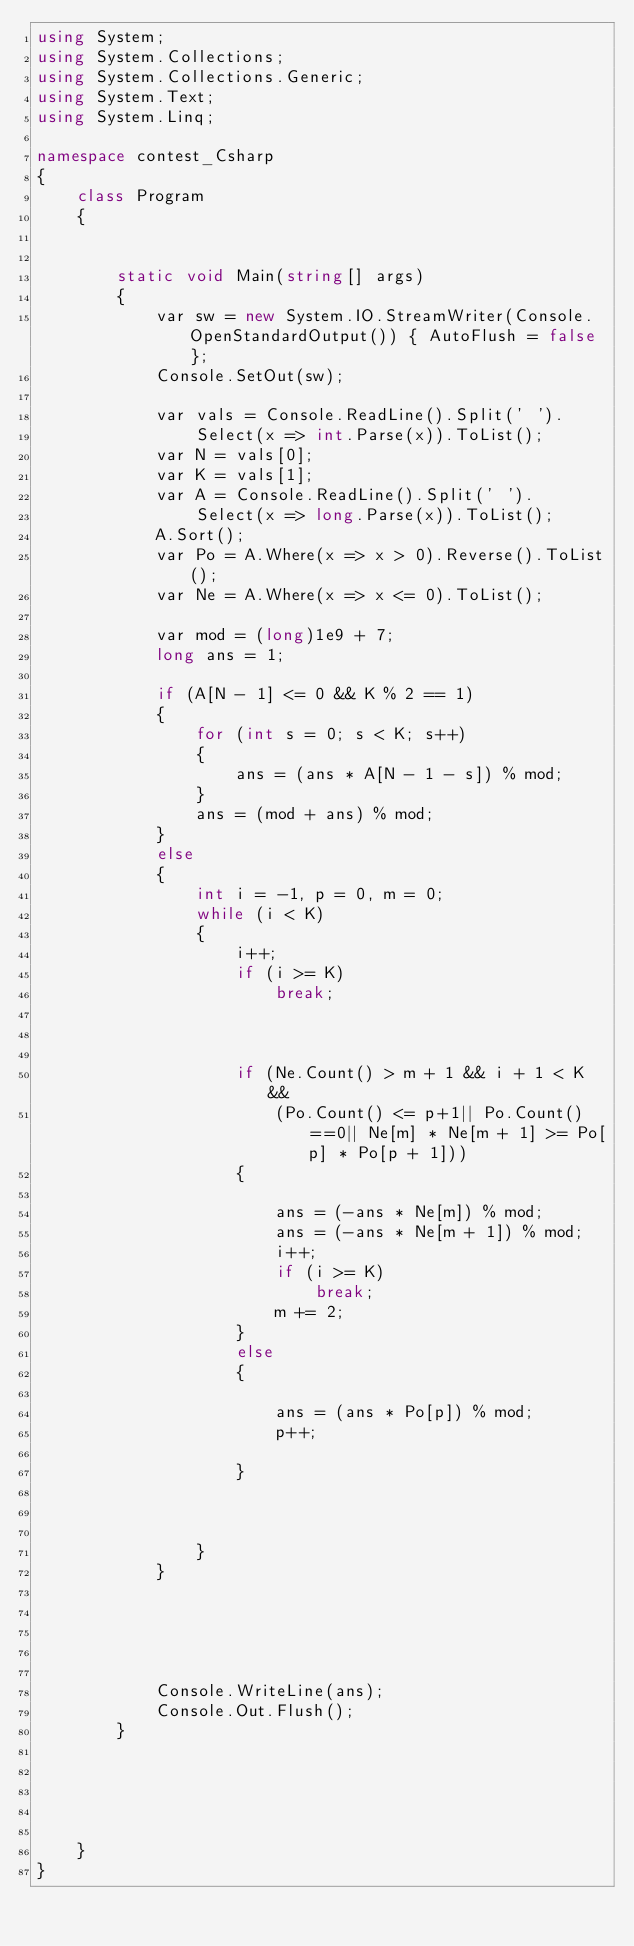<code> <loc_0><loc_0><loc_500><loc_500><_C#_>using System;
using System.Collections;
using System.Collections.Generic;
using System.Text;
using System.Linq;

namespace contest_Csharp
{
    class Program
    {


        static void Main(string[] args)
        {
            var sw = new System.IO.StreamWriter(Console.OpenStandardOutput()) { AutoFlush = false };
            Console.SetOut(sw);

            var vals = Console.ReadLine().Split(' ').
                Select(x => int.Parse(x)).ToList();
            var N = vals[0];
            var K = vals[1];
            var A = Console.ReadLine().Split(' ').
                Select(x => long.Parse(x)).ToList();
            A.Sort();
            var Po = A.Where(x => x > 0).Reverse().ToList();
            var Ne = A.Where(x => x <= 0).ToList();

            var mod = (long)1e9 + 7;
            long ans = 1;

            if (A[N - 1] <= 0 && K % 2 == 1)
            {
                for (int s = 0; s < K; s++)
                {
                    ans = (ans * A[N - 1 - s]) % mod;
                }
                ans = (mod + ans) % mod;
            }
            else
            {
                int i = -1, p = 0, m = 0;
                while (i < K)
                {
                    i++;
                    if (i >= K)
                        break;

                    

                    if (Ne.Count() > m + 1 && i + 1 < K &&
                        (Po.Count() <= p+1|| Po.Count()==0|| Ne[m] * Ne[m + 1] >= Po[p] * Po[p + 1]))
                    {

                        ans = (-ans * Ne[m]) % mod;
                        ans = (-ans * Ne[m + 1]) % mod;
                        i++;
                        if (i >= K)
                            break;
                        m += 2;
                    }
                    else
                    {

                        ans = (ans * Po[p]) % mod;
                        p++;

                    }



                }
            }





            Console.WriteLine(ans);
            Console.Out.Flush();
        }





    }
}


</code> 